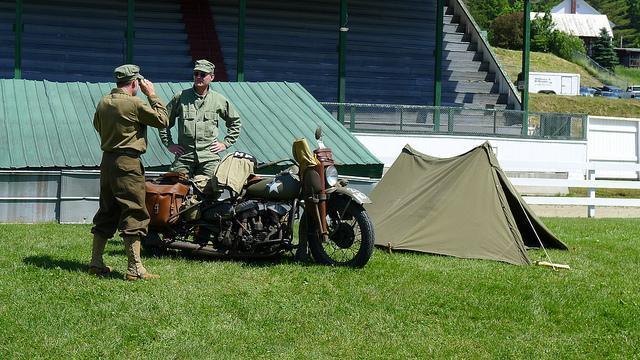How many people can you see?
Give a very brief answer. 2. How many bike on this image?
Give a very brief answer. 0. 